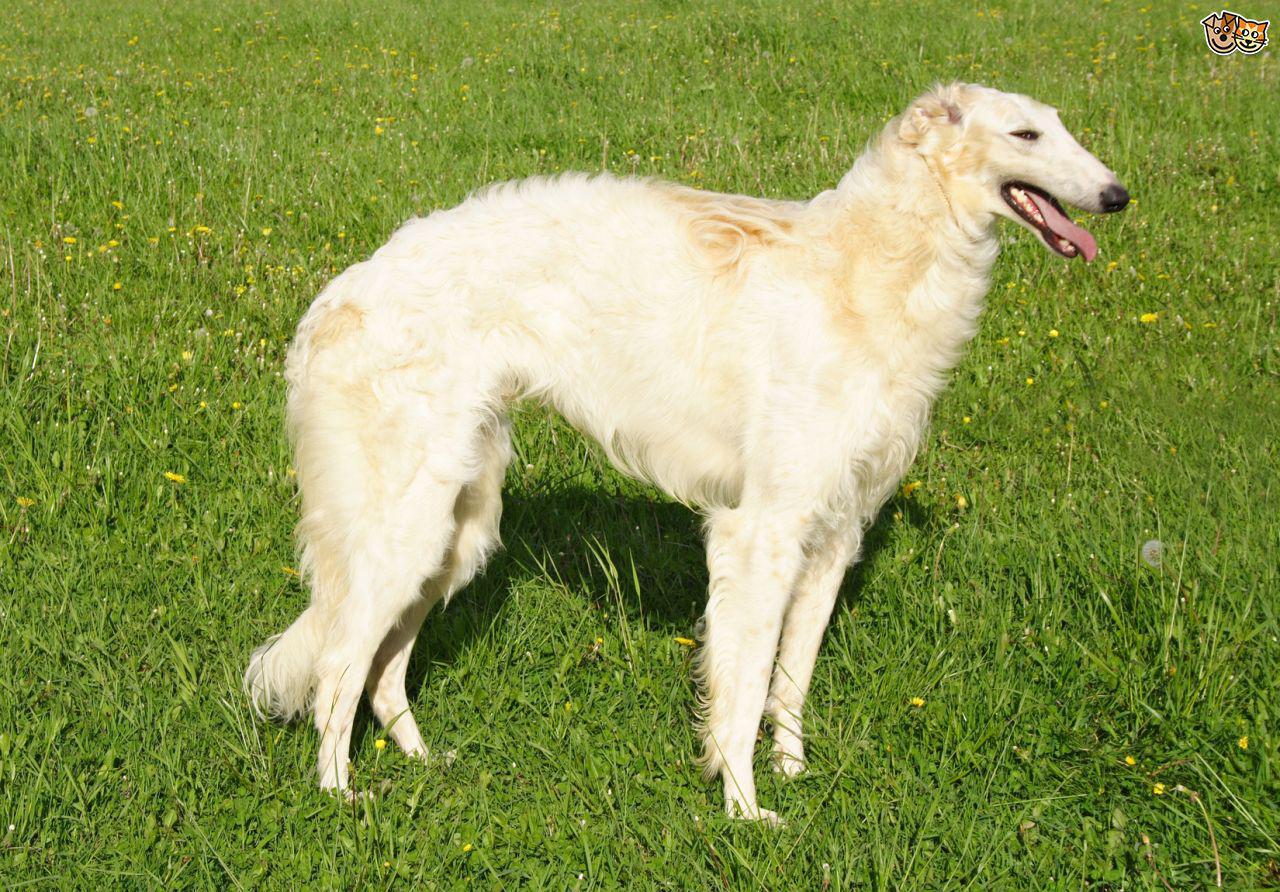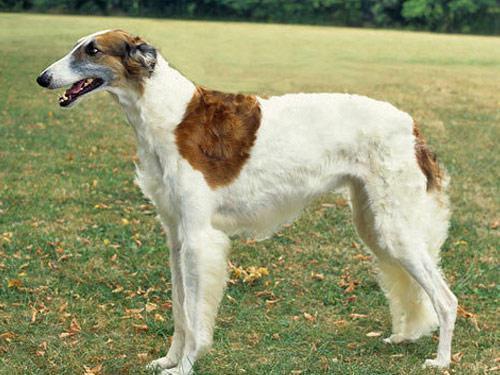The first image is the image on the left, the second image is the image on the right. Analyze the images presented: Is the assertion "Exactly three dogs are shown in grassy outdoor settings." valid? Answer yes or no. No. 